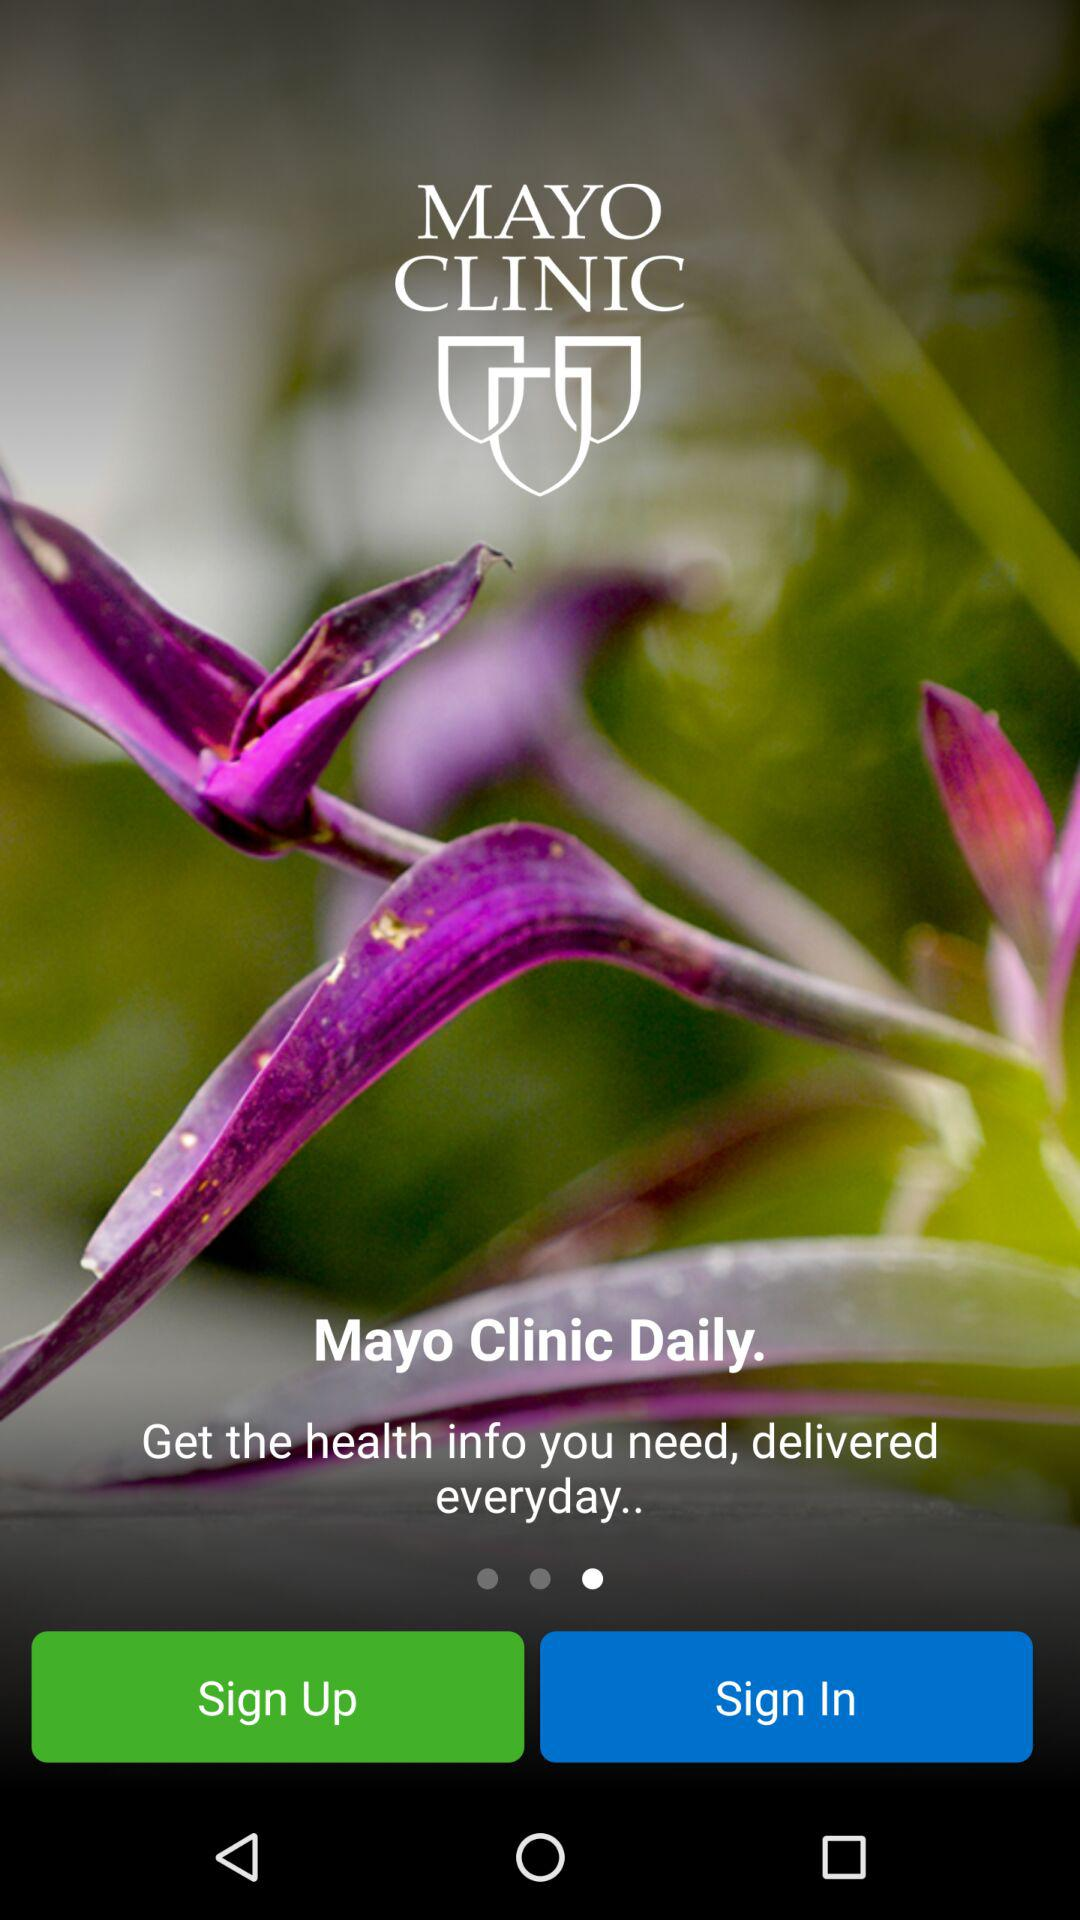What is the name of the application? The name of the application is "MAYO CLINIC". 